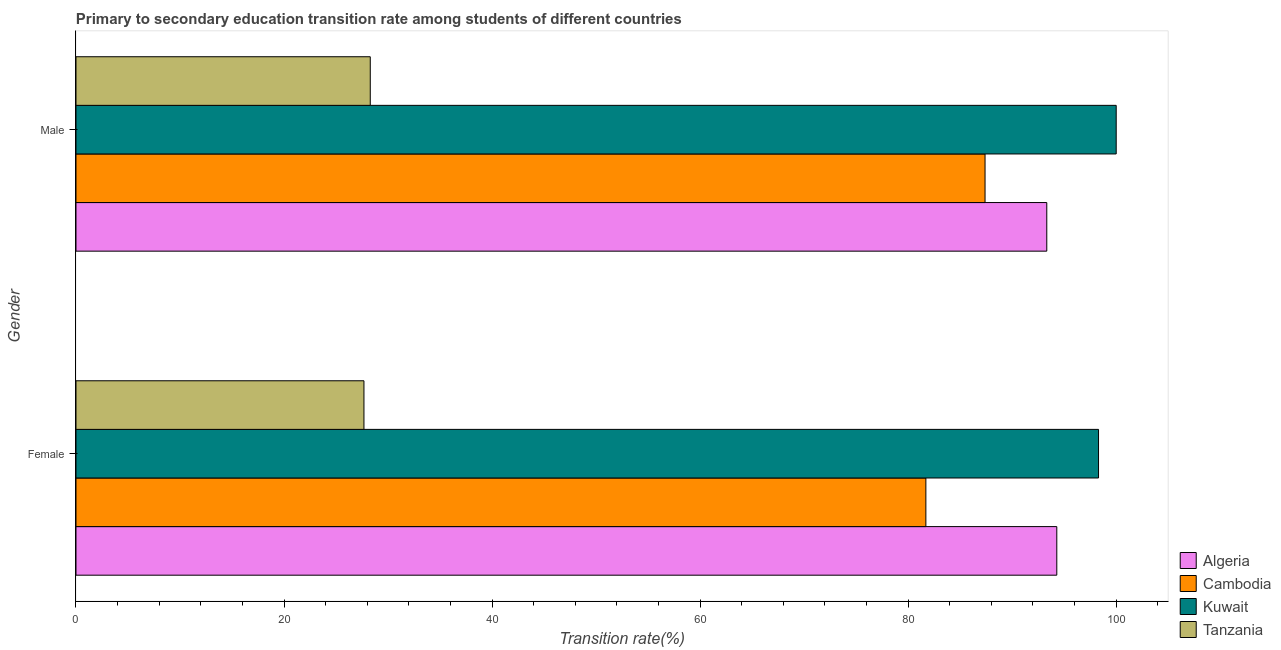How many groups of bars are there?
Give a very brief answer. 2. How many bars are there on the 2nd tick from the bottom?
Ensure brevity in your answer.  4. What is the label of the 1st group of bars from the top?
Offer a terse response. Male. What is the transition rate among male students in Tanzania?
Offer a very short reply. 28.29. Across all countries, what is the maximum transition rate among male students?
Make the answer very short. 100. Across all countries, what is the minimum transition rate among female students?
Give a very brief answer. 27.68. In which country was the transition rate among male students maximum?
Keep it short and to the point. Kuwait. In which country was the transition rate among male students minimum?
Make the answer very short. Tanzania. What is the total transition rate among male students in the graph?
Your response must be concise. 309.01. What is the difference between the transition rate among female students in Kuwait and that in Algeria?
Provide a succinct answer. 4.01. What is the difference between the transition rate among female students in Algeria and the transition rate among male students in Kuwait?
Give a very brief answer. -5.71. What is the average transition rate among female students per country?
Offer a very short reply. 75.49. What is the difference between the transition rate among female students and transition rate among male students in Cambodia?
Make the answer very short. -5.69. In how many countries, is the transition rate among female students greater than 76 %?
Ensure brevity in your answer.  3. What is the ratio of the transition rate among male students in Tanzania to that in Algeria?
Offer a very short reply. 0.3. Is the transition rate among female students in Algeria less than that in Kuwait?
Offer a terse response. Yes. In how many countries, is the transition rate among female students greater than the average transition rate among female students taken over all countries?
Provide a short and direct response. 3. What does the 3rd bar from the top in Male represents?
Offer a very short reply. Cambodia. What does the 3rd bar from the bottom in Male represents?
Your answer should be very brief. Kuwait. What is the difference between two consecutive major ticks on the X-axis?
Offer a terse response. 20. Are the values on the major ticks of X-axis written in scientific E-notation?
Your answer should be very brief. No. Where does the legend appear in the graph?
Offer a very short reply. Bottom right. How are the legend labels stacked?
Provide a short and direct response. Vertical. What is the title of the graph?
Your answer should be very brief. Primary to secondary education transition rate among students of different countries. What is the label or title of the X-axis?
Keep it short and to the point. Transition rate(%). What is the Transition rate(%) of Algeria in Female?
Provide a succinct answer. 94.29. What is the Transition rate(%) of Cambodia in Female?
Make the answer very short. 81.7. What is the Transition rate(%) in Kuwait in Female?
Make the answer very short. 98.3. What is the Transition rate(%) of Tanzania in Female?
Keep it short and to the point. 27.68. What is the Transition rate(%) of Algeria in Male?
Provide a succinct answer. 93.33. What is the Transition rate(%) of Cambodia in Male?
Your answer should be compact. 87.39. What is the Transition rate(%) of Tanzania in Male?
Provide a short and direct response. 28.29. Across all Gender, what is the maximum Transition rate(%) in Algeria?
Your answer should be very brief. 94.29. Across all Gender, what is the maximum Transition rate(%) of Cambodia?
Ensure brevity in your answer.  87.39. Across all Gender, what is the maximum Transition rate(%) of Tanzania?
Provide a short and direct response. 28.29. Across all Gender, what is the minimum Transition rate(%) of Algeria?
Offer a very short reply. 93.33. Across all Gender, what is the minimum Transition rate(%) in Cambodia?
Your answer should be very brief. 81.7. Across all Gender, what is the minimum Transition rate(%) in Kuwait?
Your answer should be very brief. 98.3. Across all Gender, what is the minimum Transition rate(%) in Tanzania?
Provide a succinct answer. 27.68. What is the total Transition rate(%) of Algeria in the graph?
Your answer should be compact. 187.62. What is the total Transition rate(%) in Cambodia in the graph?
Provide a succinct answer. 169.1. What is the total Transition rate(%) of Kuwait in the graph?
Your answer should be very brief. 198.3. What is the total Transition rate(%) of Tanzania in the graph?
Provide a short and direct response. 55.97. What is the difference between the Transition rate(%) in Algeria in Female and that in Male?
Keep it short and to the point. 0.96. What is the difference between the Transition rate(%) of Cambodia in Female and that in Male?
Offer a very short reply. -5.69. What is the difference between the Transition rate(%) of Kuwait in Female and that in Male?
Keep it short and to the point. -1.7. What is the difference between the Transition rate(%) of Tanzania in Female and that in Male?
Keep it short and to the point. -0.61. What is the difference between the Transition rate(%) of Algeria in Female and the Transition rate(%) of Cambodia in Male?
Your answer should be very brief. 6.9. What is the difference between the Transition rate(%) in Algeria in Female and the Transition rate(%) in Kuwait in Male?
Ensure brevity in your answer.  -5.71. What is the difference between the Transition rate(%) of Algeria in Female and the Transition rate(%) of Tanzania in Male?
Provide a short and direct response. 66. What is the difference between the Transition rate(%) of Cambodia in Female and the Transition rate(%) of Kuwait in Male?
Offer a terse response. -18.3. What is the difference between the Transition rate(%) of Cambodia in Female and the Transition rate(%) of Tanzania in Male?
Give a very brief answer. 53.41. What is the difference between the Transition rate(%) of Kuwait in Female and the Transition rate(%) of Tanzania in Male?
Your answer should be compact. 70.01. What is the average Transition rate(%) in Algeria per Gender?
Give a very brief answer. 93.81. What is the average Transition rate(%) in Cambodia per Gender?
Offer a very short reply. 84.55. What is the average Transition rate(%) in Kuwait per Gender?
Keep it short and to the point. 99.15. What is the average Transition rate(%) of Tanzania per Gender?
Keep it short and to the point. 27.99. What is the difference between the Transition rate(%) of Algeria and Transition rate(%) of Cambodia in Female?
Keep it short and to the point. 12.59. What is the difference between the Transition rate(%) of Algeria and Transition rate(%) of Kuwait in Female?
Give a very brief answer. -4.01. What is the difference between the Transition rate(%) in Algeria and Transition rate(%) in Tanzania in Female?
Your response must be concise. 66.61. What is the difference between the Transition rate(%) of Cambodia and Transition rate(%) of Kuwait in Female?
Provide a short and direct response. -16.6. What is the difference between the Transition rate(%) of Cambodia and Transition rate(%) of Tanzania in Female?
Provide a short and direct response. 54.02. What is the difference between the Transition rate(%) in Kuwait and Transition rate(%) in Tanzania in Female?
Keep it short and to the point. 70.62. What is the difference between the Transition rate(%) of Algeria and Transition rate(%) of Cambodia in Male?
Make the answer very short. 5.94. What is the difference between the Transition rate(%) of Algeria and Transition rate(%) of Kuwait in Male?
Your answer should be very brief. -6.67. What is the difference between the Transition rate(%) of Algeria and Transition rate(%) of Tanzania in Male?
Your response must be concise. 65.04. What is the difference between the Transition rate(%) in Cambodia and Transition rate(%) in Kuwait in Male?
Give a very brief answer. -12.61. What is the difference between the Transition rate(%) in Cambodia and Transition rate(%) in Tanzania in Male?
Make the answer very short. 59.1. What is the difference between the Transition rate(%) in Kuwait and Transition rate(%) in Tanzania in Male?
Make the answer very short. 71.71. What is the ratio of the Transition rate(%) of Algeria in Female to that in Male?
Make the answer very short. 1.01. What is the ratio of the Transition rate(%) of Cambodia in Female to that in Male?
Your answer should be compact. 0.93. What is the ratio of the Transition rate(%) of Kuwait in Female to that in Male?
Your response must be concise. 0.98. What is the ratio of the Transition rate(%) of Tanzania in Female to that in Male?
Your response must be concise. 0.98. What is the difference between the highest and the second highest Transition rate(%) in Algeria?
Offer a very short reply. 0.96. What is the difference between the highest and the second highest Transition rate(%) of Cambodia?
Offer a terse response. 5.69. What is the difference between the highest and the second highest Transition rate(%) in Kuwait?
Provide a succinct answer. 1.7. What is the difference between the highest and the second highest Transition rate(%) of Tanzania?
Your answer should be very brief. 0.61. What is the difference between the highest and the lowest Transition rate(%) in Algeria?
Give a very brief answer. 0.96. What is the difference between the highest and the lowest Transition rate(%) of Cambodia?
Your answer should be very brief. 5.69. What is the difference between the highest and the lowest Transition rate(%) in Kuwait?
Keep it short and to the point. 1.7. What is the difference between the highest and the lowest Transition rate(%) of Tanzania?
Ensure brevity in your answer.  0.61. 